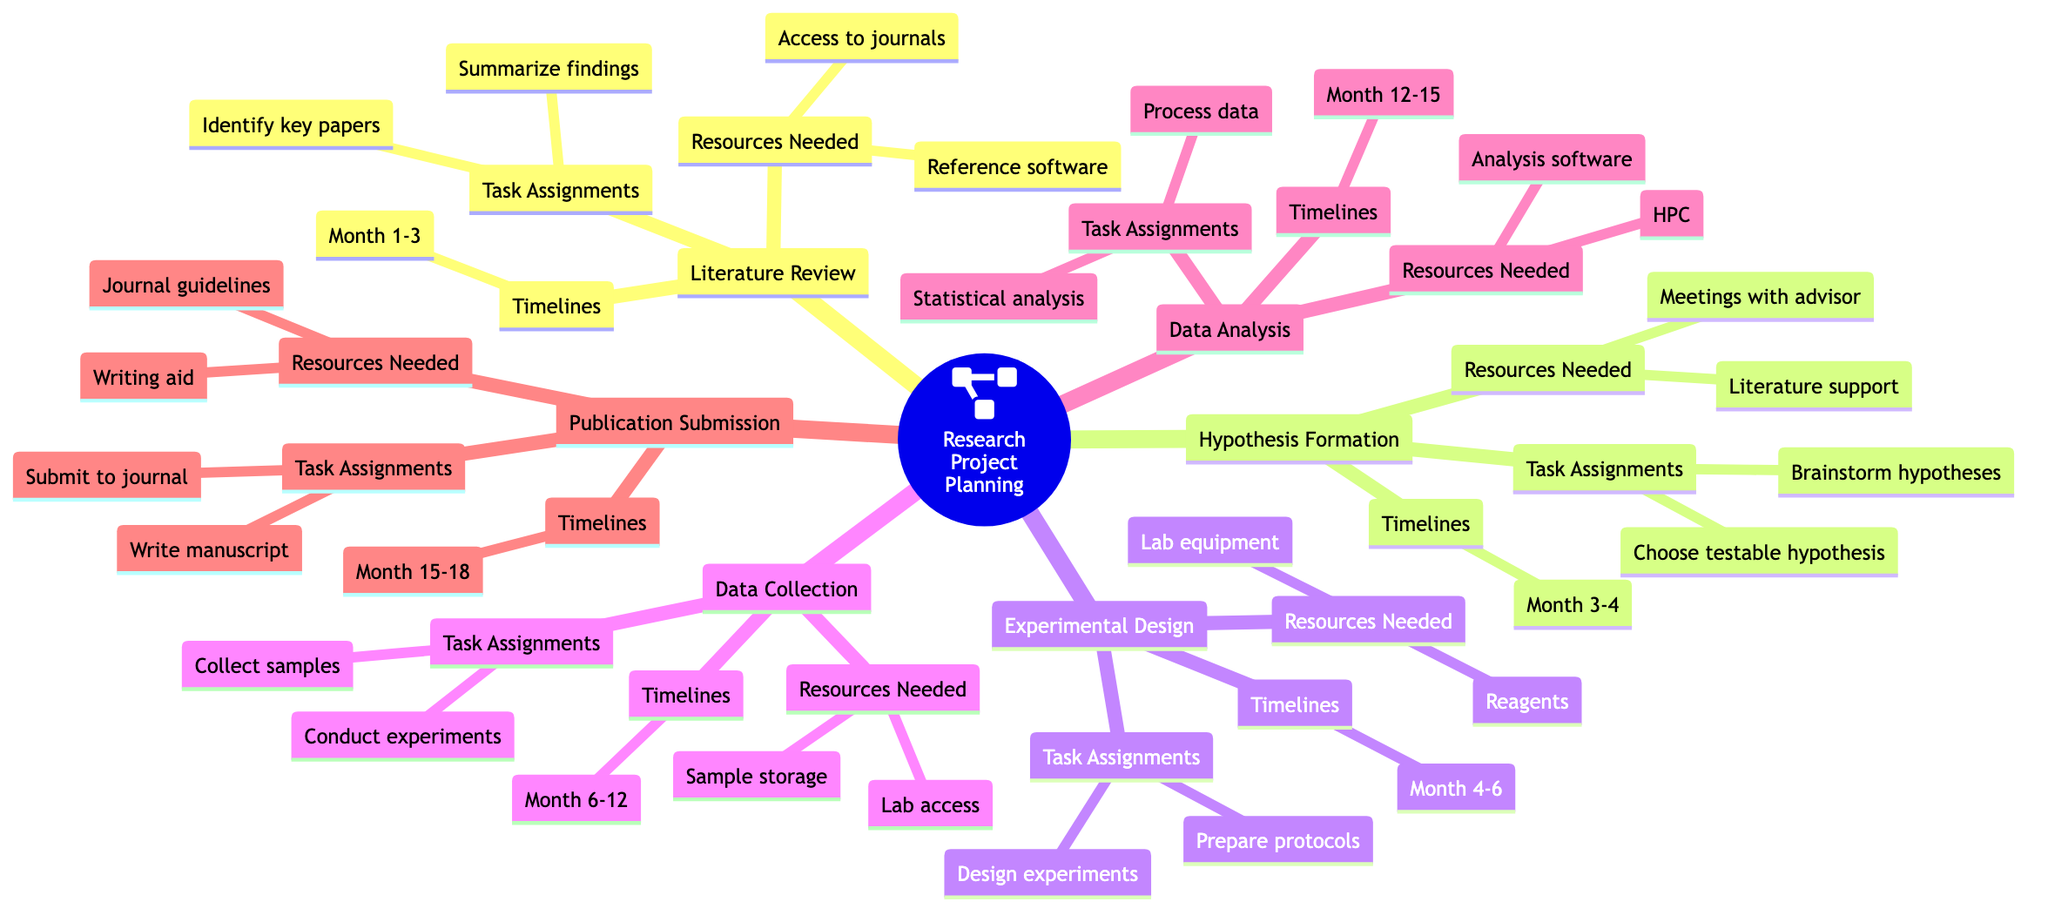What is the central node of the Research Project Planning section? The central node is labeled "Overall Research Project." It serves as the primary focus of the branch and encapsulates the main theme of research project planning.
Answer: Overall Research Project How many sub-nodes are listed under Data Analysis? The "Data Analysis" branch has six clearly identifiable sub-nodes: "Data Preprocessing," "Statistical Tests," "Software/Tools Used," "Data Visualization," "Interpretation of Results," and "Error Analysis." Counting these gives a total of six sub-nodes.
Answer: 6 What timeline is allocated for the Literature Review phase? Under the Literature Review branch, the timeline provided is "Month 1-3," indicating the period designated for completing tasks in this phase.
Answer: Month 1-3 What are the key proteins identified in the Biological Pathways section? The Biological Pathways section lists two key proteins, which are "Protein A" and "Protein B." This indicates the significant components being studied in that particular pathway.
Answer: Protein A, Protein B Which task is assigned under Data Collection? The sub-node under Data Collection mentions two tasks: "Conduct experiments" and "Collect samples." Both tasks are essential for this phase of the research project.
Answer: Conduct experiments What is required for the timeline of Publication Submission? The timeline for the Publication Submission phase is stated as "Month 15-18," outlining the specific period when tasks related to publishing should be completed.
Answer: Month 15-18 What are the two main activities listed under Skill Acquisition in Academic Career Development? Under the Skill Acquisition branch, two activities are explicitly mentioned: "Lab Techniques" and "Data Analysis." These represent crucial skills for a biomedical researcher.
Answer: Lab Techniques, Data Analysis How many branches are present under Grant Proposal Structure? The Grant Proposal Structure section has six main branches: "Abstract," "Specific Aims," "Background and Significance," "Preliminary Data," "Research Design and Methods," and "Budget Justification." This total equals six branches.
Answer: 6 